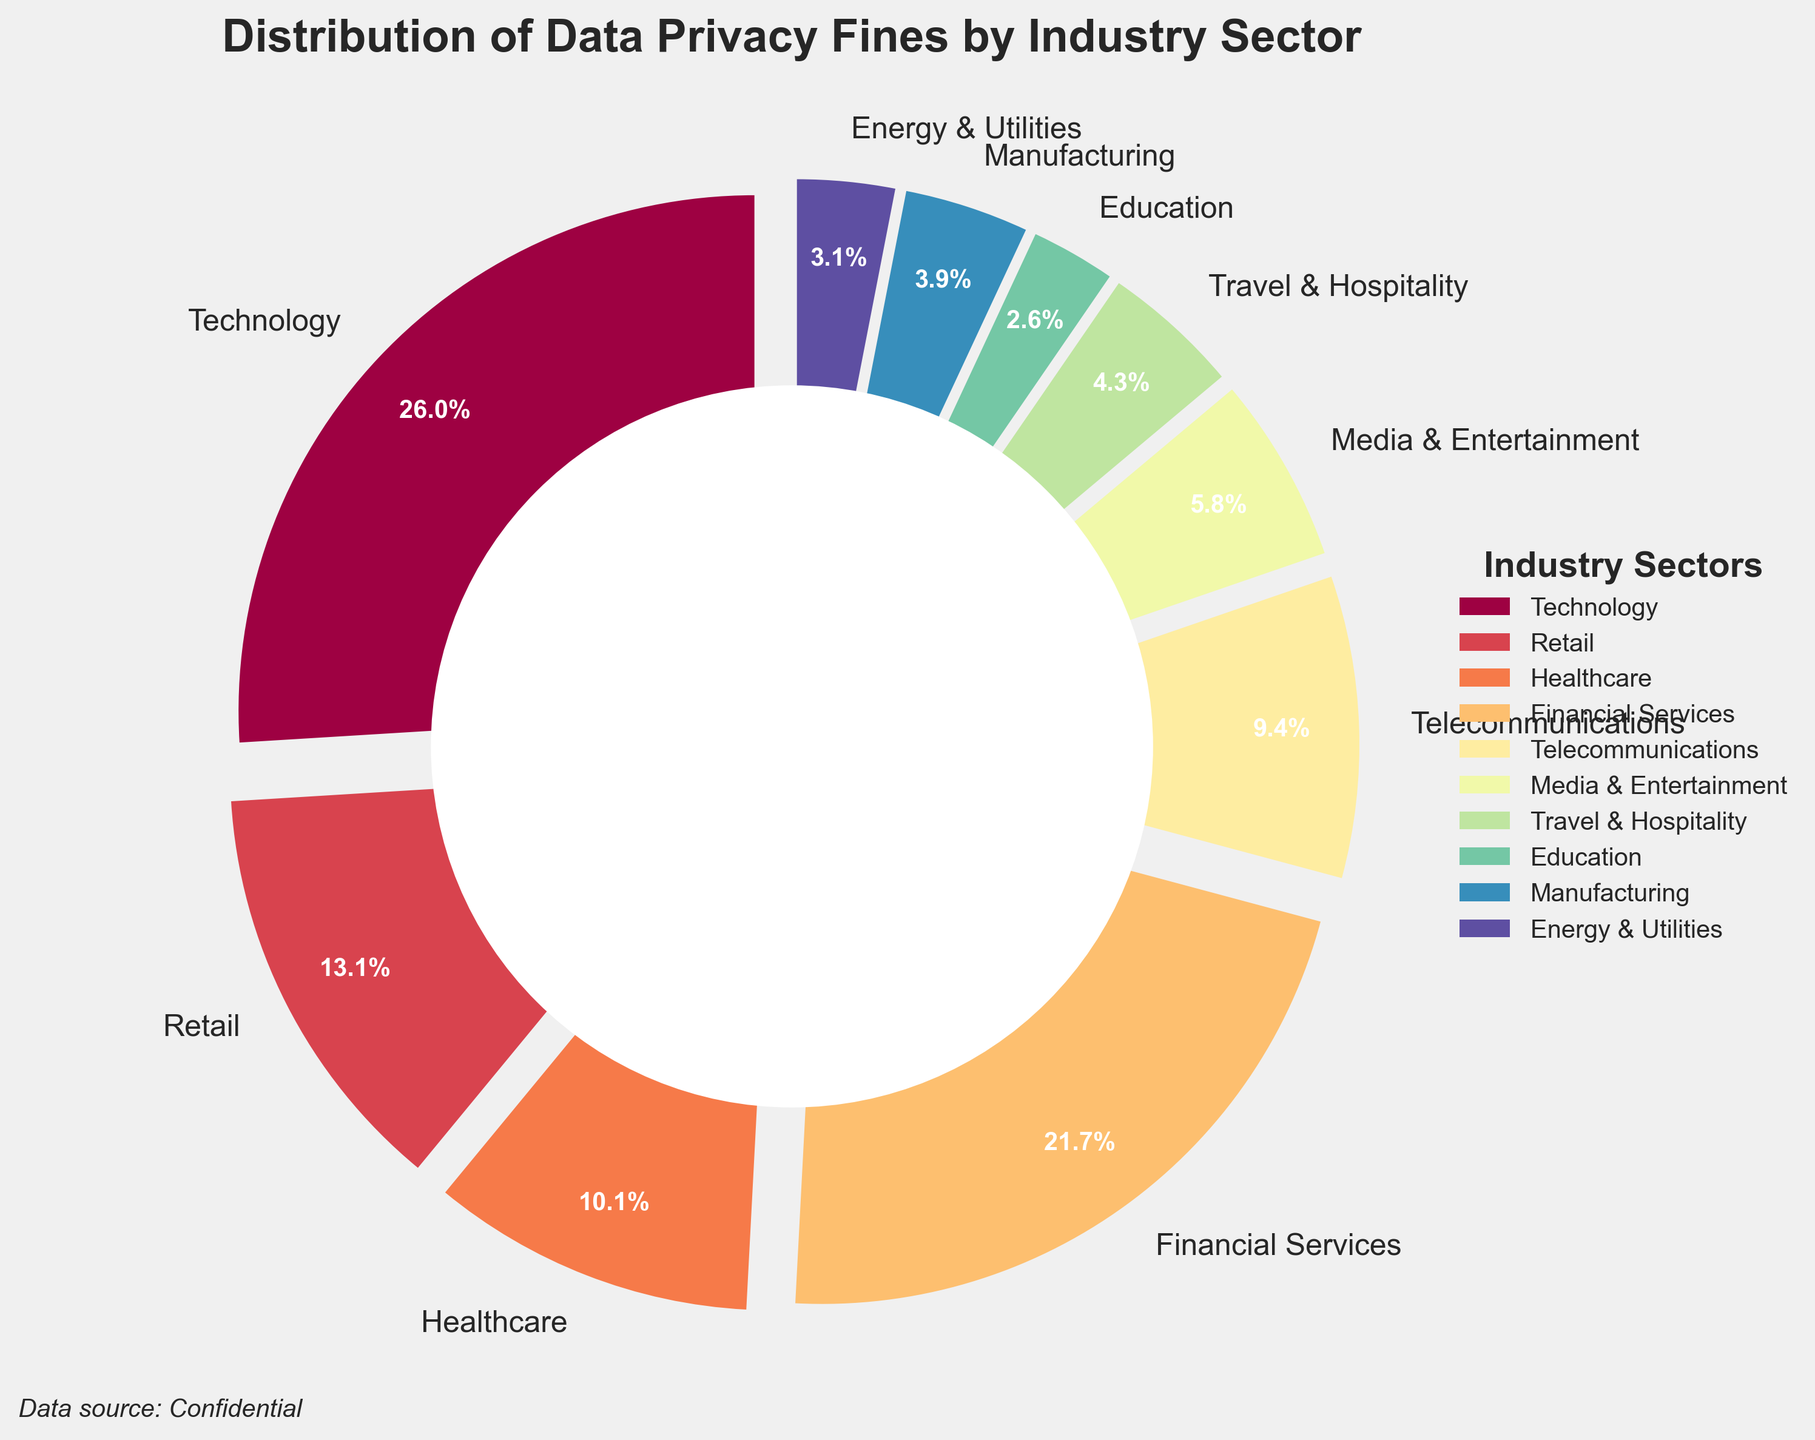Which industry sector has the largest share of data privacy fines? By examining the pie chart, it's clear that the Technology sector has the largest wedge, indicating it has the largest share of fines.
Answer: Technology How much more are the fines in the Technology sector compared to the Media & Entertainment sector? The fine amount in the Technology sector is 187 million USD, and in the Media & Entertainment sector, it’s 42 million USD. The difference is 187 - 42 = 145 million USD.
Answer: 145 million USD What percentage of the total fines are attributed to the Financial Services and Healthcare sectors combined? The Financial Services sector accounts for 156 million USD and the Healthcare sector accounts for 73 million USD. The combined amount is 156 + 73 = 229 million USD. The total fines across all sectors sum up to 720 million USD. Therefore, the combined percentage is (229 / 720) * 100 ≈ 31.8%.
Answer: 31.8% Is the fine amount in the Retail sector greater than in the Telecommunications sector? The fines in the Retail sector are 94 million USD, whereas in the Telecommunications sector they are 68 million USD. Therefore, the Retail sector has greater fines.
Answer: Yes What is the average fine amount across all industry sectors? The total fine amount across all sectors is 720 million USD, and there are 10 sectors. Therefore, the average fine amount is 720 / 10 = 72 million USD.
Answer: 72 million USD Which three industry sectors have the smallest fine amounts? By looking at the smallest wedges in the pie chart, the sectors with the smallest fines are Education, Energy & Utilities, and Manufacturing, with fine amounts of 19, 22, and 28 million USD respectively.
Answer: Education, Energy & Utilities, Manufacturing How does the total fine amount in the Technology and Financial Services sectors compare to the total fines in all other sectors combined? The Technology sector has fines of 187 million USD, and the Financial Services sector has 156 million USD. Their combined amount is 187 + 156 = 343 million USD. The total fines for all sectors are 720 million USD, so the combined amount of all other sectors is 720 - 343 = 377 million USD. Therefore, the combined fines in Technology and Financial Services are less than the rest by 377 - 343 = 34 million USD.
Answer: 34 million USD Which industry sector accounts for approximately 9.4% of the fines? By examining the pie chart, the sector with approximately 9.4% of the fines is Retail, which equates to 94 million USD of the total 720 million USD.
Answer: Retail Between the Healthcare and Telecommunications sectors, which one has a smaller share of fines? By comparing the wedges, it is evident that the Telecommunications sector has a smaller share of 68 million USD, whereas the Healthcare sector has 73 million USD.
Answer: Telecommunications 